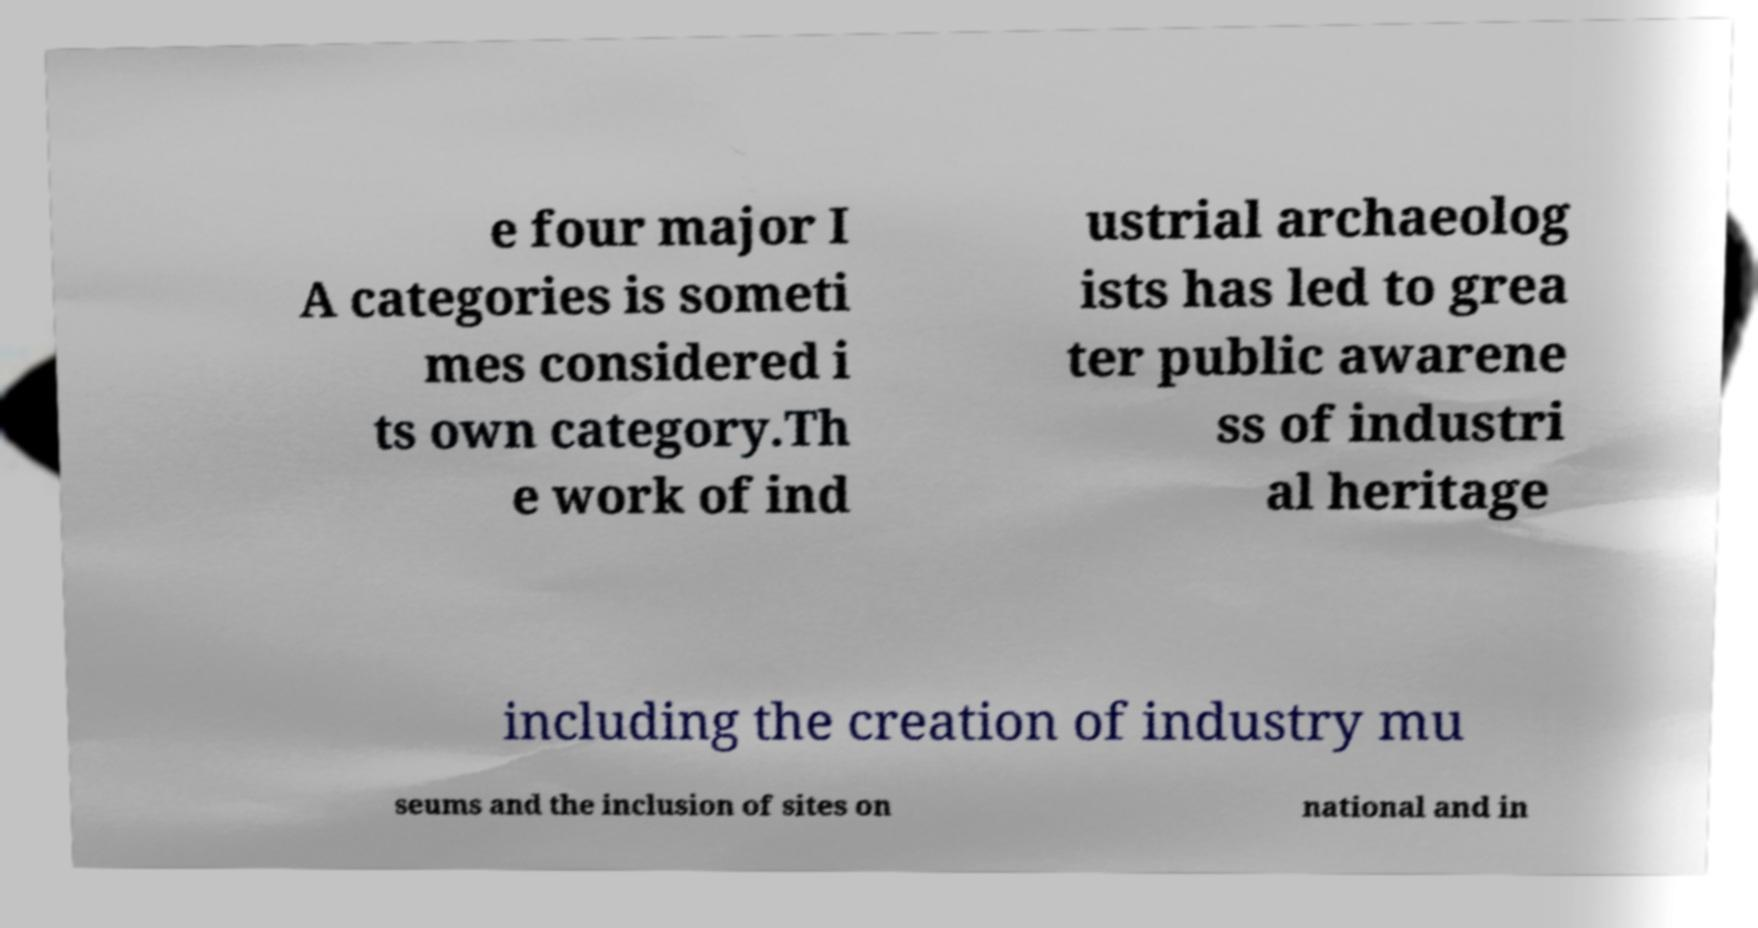Please identify and transcribe the text found in this image. e four major I A categories is someti mes considered i ts own category.Th e work of ind ustrial archaeolog ists has led to grea ter public awarene ss of industri al heritage including the creation of industry mu seums and the inclusion of sites on national and in 